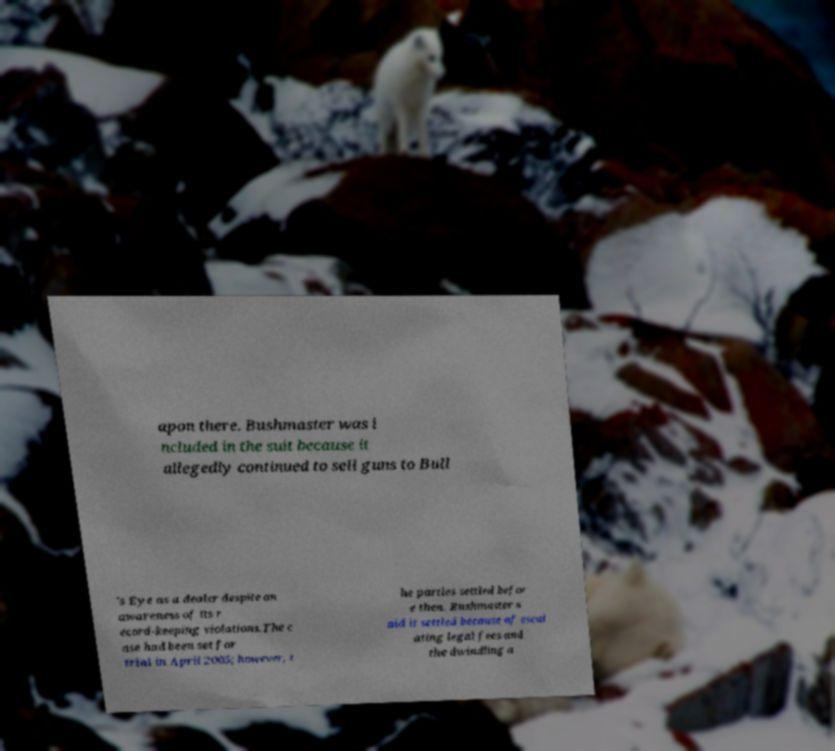There's text embedded in this image that I need extracted. Can you transcribe it verbatim? apon there. Bushmaster was i ncluded in the suit because it allegedly continued to sell guns to Bull 's Eye as a dealer despite an awareness of its r ecord-keeping violations.The c ase had been set for trial in April 2005; however, t he parties settled befor e then. Bushmaster s aid it settled because of escal ating legal fees and the dwindling a 